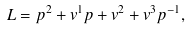Convert formula to latex. <formula><loc_0><loc_0><loc_500><loc_500>L = p ^ { 2 } + v ^ { 1 } p + v ^ { 2 } + v ^ { 3 } p ^ { - 1 } ,</formula> 